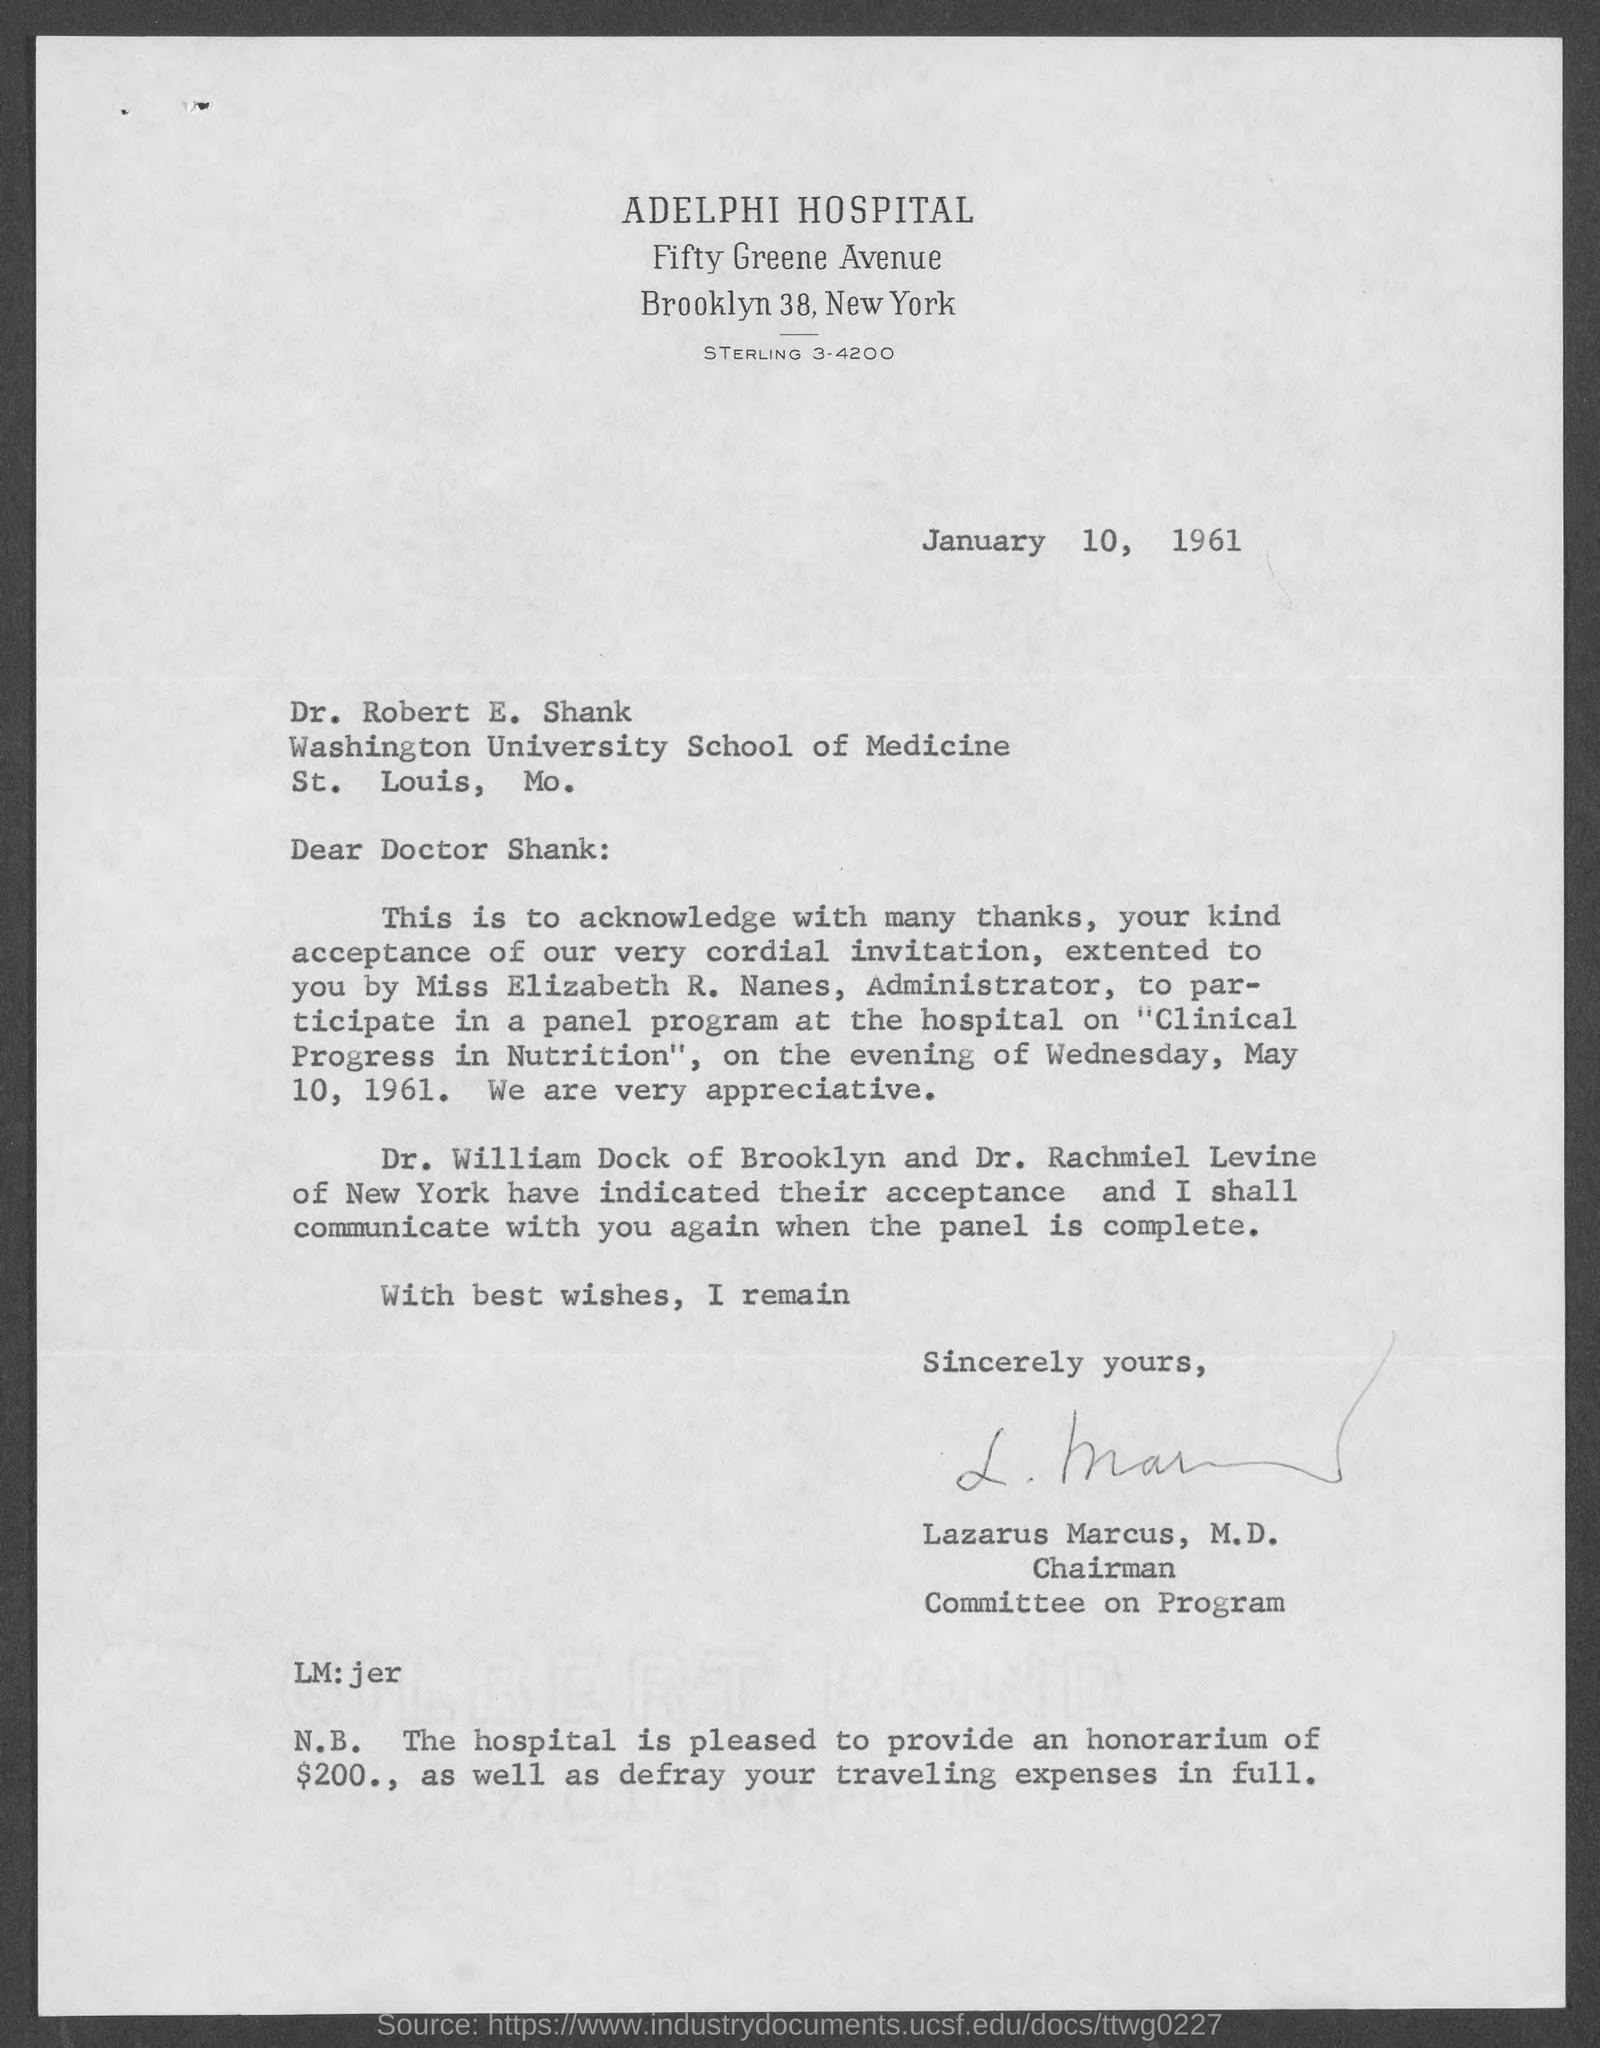What is the name of the hospital in the  letter head?
Offer a terse response. Adelphi Hospital. To whom this letter is written to?
Your response must be concise. Doctor shank. To which university does Dr. Robert E. Shank belong to?
Give a very brief answer. Washington university. Who wrote this letter?
Make the answer very short. Lazarus marcus. Who is the chairman of committee on program?
Offer a terse response. Lazarus marcus. What is the amount that hospital is pleased to provide as an honorarium to dr. robert e. shank?
Keep it short and to the point. $200. What is the address of washington university school of medicine?
Offer a terse response. St. Louis, MO. On what day of the week is the invitation is for?
Give a very brief answer. Wednesday. 